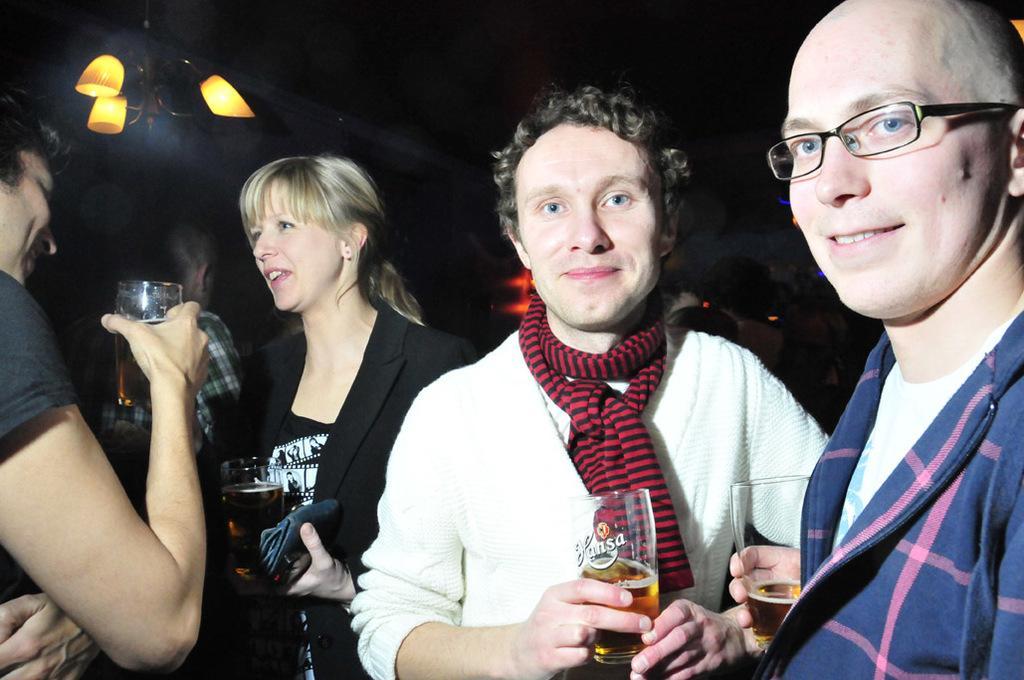Could you give a brief overview of what you see in this image? This 4 persons are highlighted in this picture. This 4 persons are holding a glass. This person wore spectacles. This man wore scarf. This woman wore black suit. 